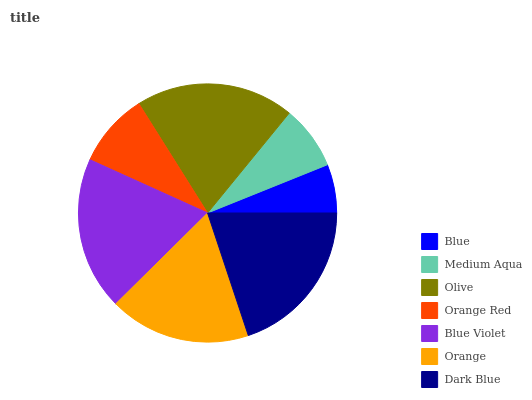Is Blue the minimum?
Answer yes or no. Yes. Is Dark Blue the maximum?
Answer yes or no. Yes. Is Medium Aqua the minimum?
Answer yes or no. No. Is Medium Aqua the maximum?
Answer yes or no. No. Is Medium Aqua greater than Blue?
Answer yes or no. Yes. Is Blue less than Medium Aqua?
Answer yes or no. Yes. Is Blue greater than Medium Aqua?
Answer yes or no. No. Is Medium Aqua less than Blue?
Answer yes or no. No. Is Orange the high median?
Answer yes or no. Yes. Is Orange the low median?
Answer yes or no. Yes. Is Olive the high median?
Answer yes or no. No. Is Medium Aqua the low median?
Answer yes or no. No. 